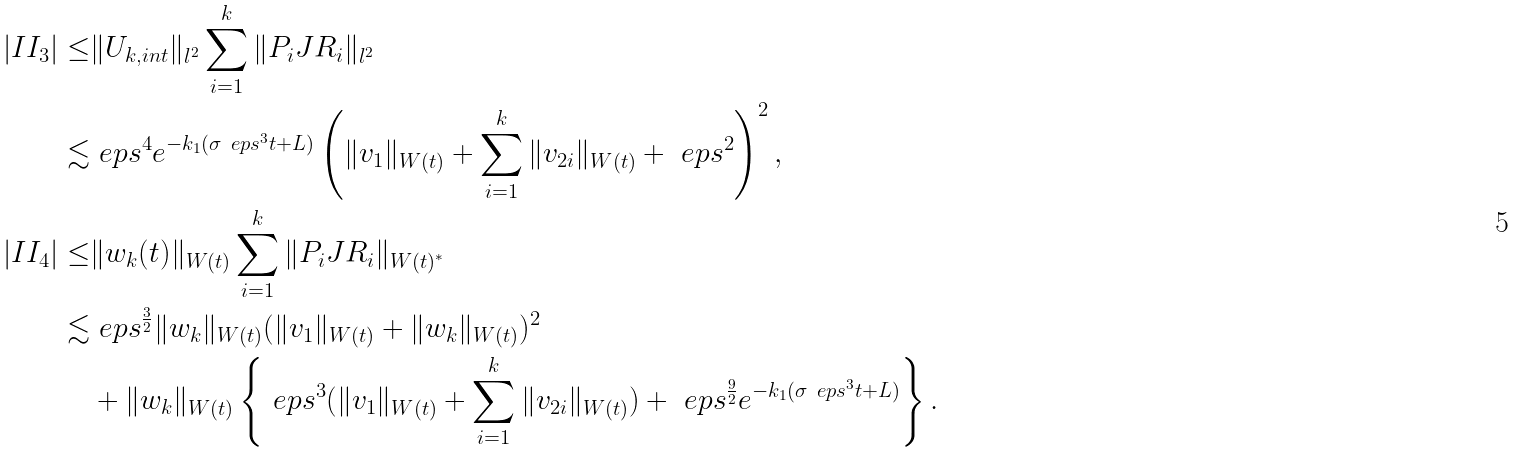Convert formula to latex. <formula><loc_0><loc_0><loc_500><loc_500>| I I _ { 3 } | \leq & \| U _ { k , i n t } \| _ { l ^ { 2 } } \sum _ { i = 1 } ^ { k } \| P _ { i } J R _ { i } \| _ { l ^ { 2 } } \\ \lesssim & \ e p s ^ { 4 } e ^ { - k _ { 1 } ( \sigma \ e p s ^ { 3 } t + L ) } \left ( \| v _ { 1 } \| _ { W ( t ) } + \sum _ { i = 1 } ^ { k } \| v _ { 2 i } \| _ { W ( t ) } + \ e p s ^ { 2 } \right ) ^ { 2 } , \\ | I I _ { 4 } | \leq & \| w _ { k } ( t ) \| _ { W ( t ) } \sum _ { i = 1 } ^ { k } \| P _ { i } J R _ { i } \| _ { W ( t ) ^ { * } } \\ \lesssim & \ e p s ^ { \frac { 3 } { 2 } } \| w _ { k } \| _ { W ( t ) } ( \| v _ { 1 } \| _ { W ( t ) } + \| w _ { k } \| _ { W ( t ) } ) ^ { 2 } \\ & + \| w _ { k } \| _ { W ( t ) } \left \{ \ e p s ^ { 3 } ( \| v _ { 1 } \| _ { W ( t ) } + \sum _ { i = 1 } ^ { k } \| v _ { 2 i } \| _ { W ( t ) } ) + \ e p s ^ { \frac { 9 } { 2 } } e ^ { - k _ { 1 } ( \sigma \ e p s ^ { 3 } t + L ) } \right \} .</formula> 